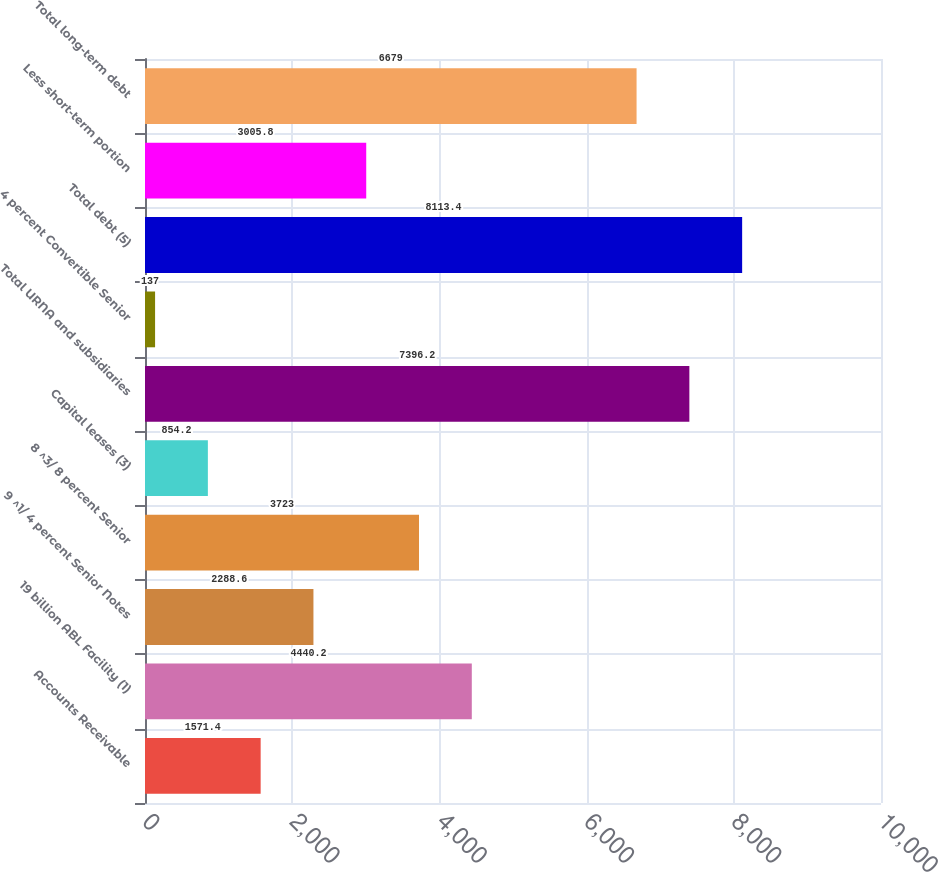<chart> <loc_0><loc_0><loc_500><loc_500><bar_chart><fcel>Accounts Receivable<fcel>19 billion ABL Facility (1)<fcel>9 ^1/ 4 percent Senior Notes<fcel>8 ^3/ 8 percent Senior<fcel>Capital leases (3)<fcel>Total URNA and subsidiaries<fcel>4 percent Convertible Senior<fcel>Total debt (5)<fcel>Less short-term portion<fcel>Total long-term debt<nl><fcel>1571.4<fcel>4440.2<fcel>2288.6<fcel>3723<fcel>854.2<fcel>7396.2<fcel>137<fcel>8113.4<fcel>3005.8<fcel>6679<nl></chart> 